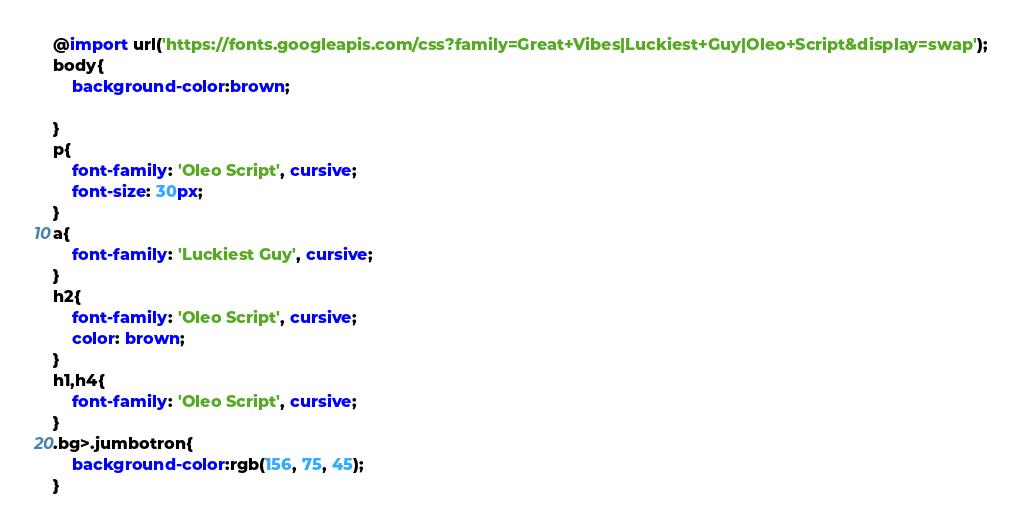<code> <loc_0><loc_0><loc_500><loc_500><_CSS_>@import url('https://fonts.googleapis.com/css?family=Great+Vibes|Luckiest+Guy|Oleo+Script&display=swap');
body{
    background-color:brown;
  
}
p{
    font-family: 'Oleo Script', cursive;
    font-size: 30px;
}
a{
    font-family: 'Luckiest Guy', cursive;
}
h2{
    font-family: 'Oleo Script', cursive;
    color: brown;
}
h1,h4{
    font-family: 'Oleo Script', cursive;
}
.bg>.jumbotron{
    background-color:rgb(156, 75, 45);
}</code> 